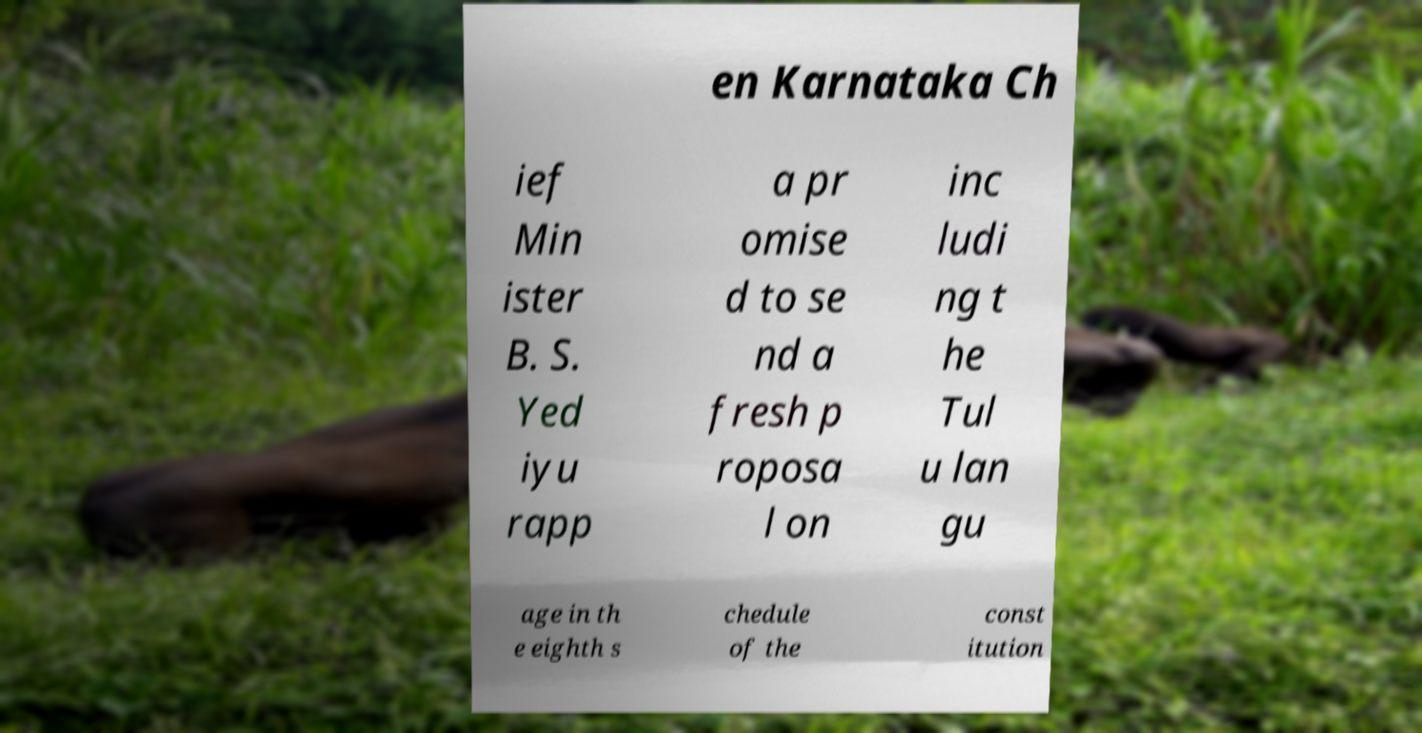Can you read and provide the text displayed in the image?This photo seems to have some interesting text. Can you extract and type it out for me? en Karnataka Ch ief Min ister B. S. Yed iyu rapp a pr omise d to se nd a fresh p roposa l on inc ludi ng t he Tul u lan gu age in th e eighth s chedule of the const itution 